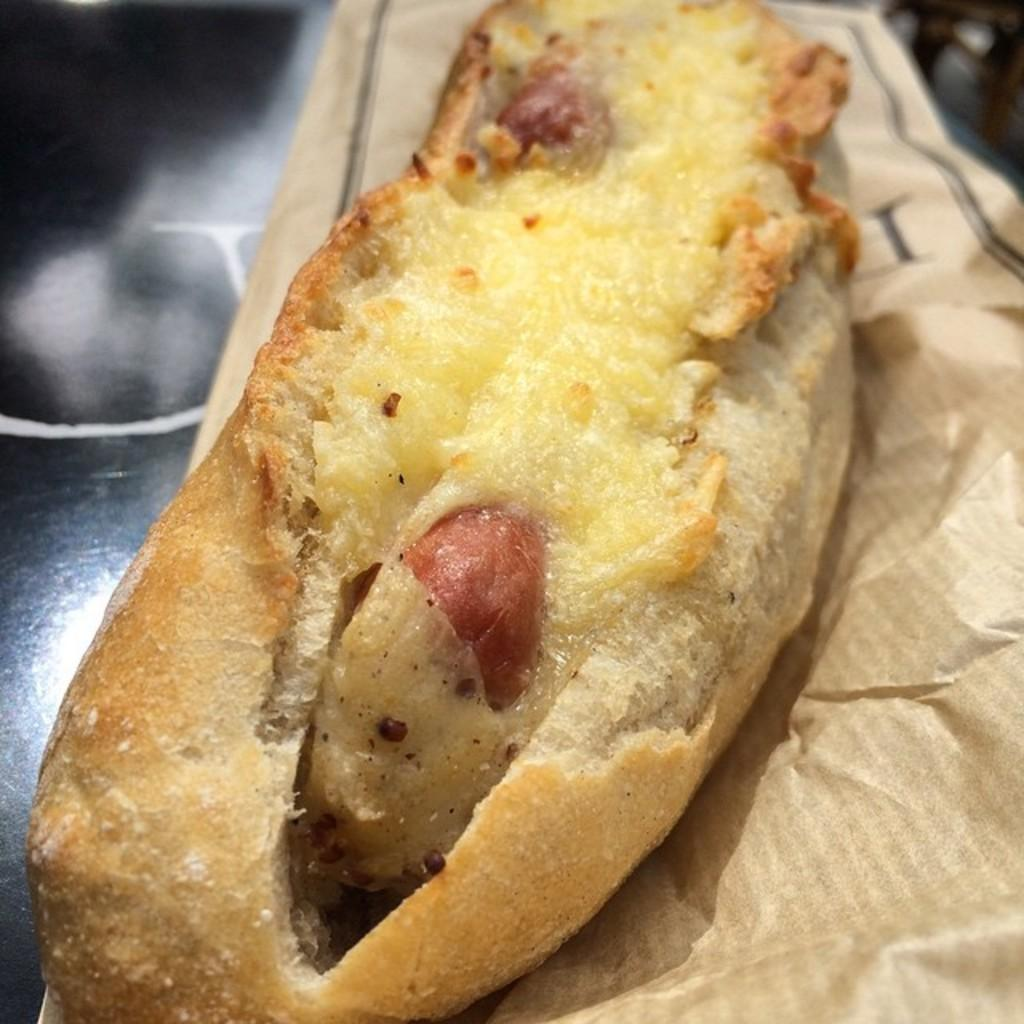What is the main subject of the image? The main subject of the image is food. Where is the food located in the image? The food is in the center of the image. What type of material is used to wrap or cover the food? There is a brown paper in the image. How many chairs are visible in the image? There are no chairs present in the image. What is the plot of the story being told in the image? The image does not depict a story or plot; it simply shows food in the center with brown paper. 